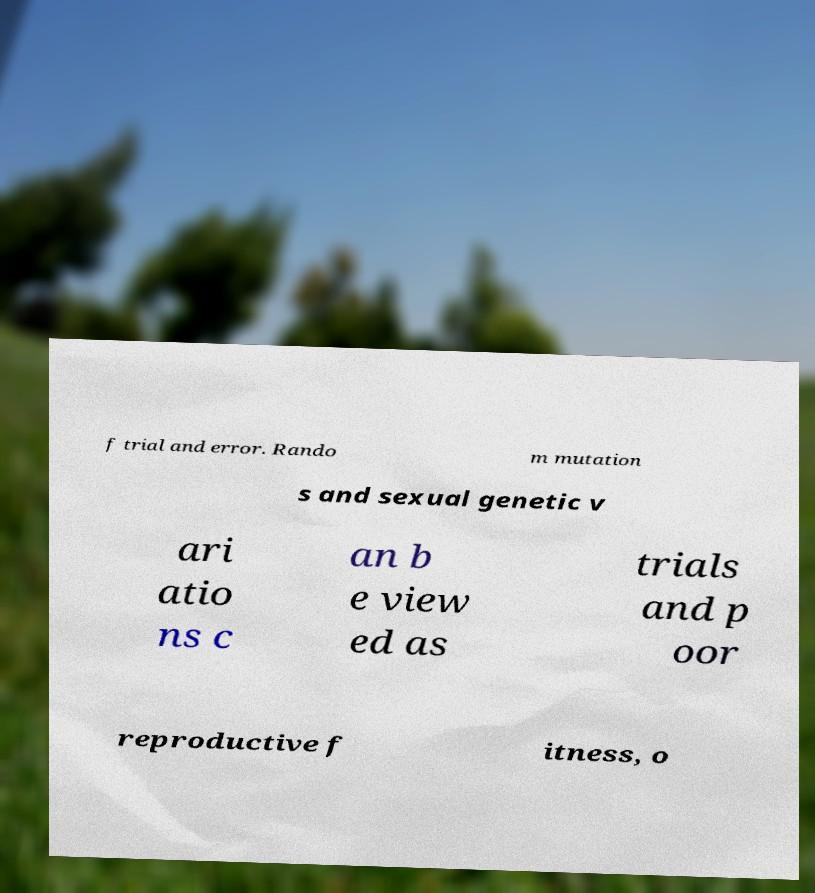There's text embedded in this image that I need extracted. Can you transcribe it verbatim? f trial and error. Rando m mutation s and sexual genetic v ari atio ns c an b e view ed as trials and p oor reproductive f itness, o 